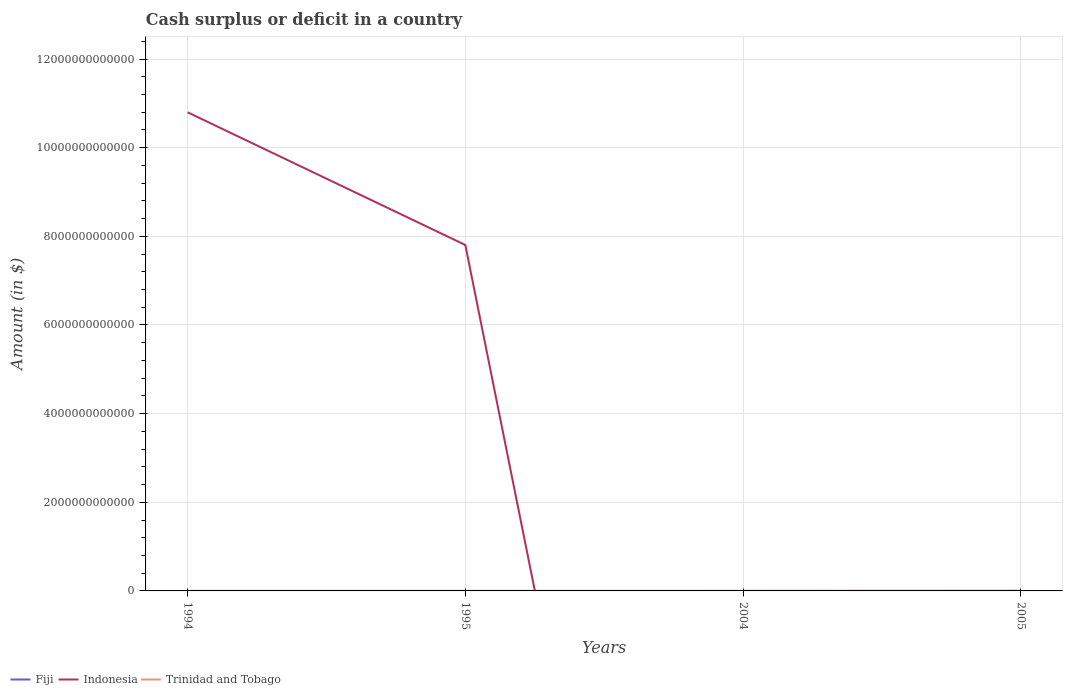Is the number of lines equal to the number of legend labels?
Offer a terse response. No. Across all years, what is the maximum amount of cash surplus or deficit in Indonesia?
Keep it short and to the point. 0. What is the total amount of cash surplus or deficit in Trinidad and Tobago in the graph?
Offer a terse response. -4.17e+09. Is the amount of cash surplus or deficit in Fiji strictly greater than the amount of cash surplus or deficit in Trinidad and Tobago over the years?
Your answer should be very brief. Yes. How many lines are there?
Give a very brief answer. 2. How many years are there in the graph?
Offer a very short reply. 4. What is the difference between two consecutive major ticks on the Y-axis?
Provide a short and direct response. 2.00e+12. How many legend labels are there?
Your answer should be compact. 3. What is the title of the graph?
Provide a short and direct response. Cash surplus or deficit in a country. What is the label or title of the Y-axis?
Provide a succinct answer. Amount (in $). What is the Amount (in $) of Indonesia in 1994?
Your answer should be compact. 1.08e+13. What is the Amount (in $) in Trinidad and Tobago in 1994?
Give a very brief answer. 1.14e+08. What is the Amount (in $) of Fiji in 1995?
Make the answer very short. 0. What is the Amount (in $) of Indonesia in 1995?
Provide a short and direct response. 7.80e+12. What is the Amount (in $) in Fiji in 2004?
Provide a short and direct response. 0. What is the Amount (in $) of Indonesia in 2004?
Provide a succinct answer. 0. What is the Amount (in $) in Trinidad and Tobago in 2004?
Your answer should be compact. 1.61e+09. What is the Amount (in $) of Fiji in 2005?
Provide a succinct answer. 0. What is the Amount (in $) of Trinidad and Tobago in 2005?
Provide a short and direct response. 5.78e+09. Across all years, what is the maximum Amount (in $) in Indonesia?
Your answer should be very brief. 1.08e+13. Across all years, what is the maximum Amount (in $) in Trinidad and Tobago?
Offer a very short reply. 5.78e+09. Across all years, what is the minimum Amount (in $) in Indonesia?
Your response must be concise. 0. Across all years, what is the minimum Amount (in $) in Trinidad and Tobago?
Offer a very short reply. 0. What is the total Amount (in $) of Indonesia in the graph?
Provide a short and direct response. 1.86e+13. What is the total Amount (in $) in Trinidad and Tobago in the graph?
Make the answer very short. 7.50e+09. What is the difference between the Amount (in $) in Indonesia in 1994 and that in 1995?
Your response must be concise. 2.99e+12. What is the difference between the Amount (in $) of Trinidad and Tobago in 1994 and that in 2004?
Offer a very short reply. -1.50e+09. What is the difference between the Amount (in $) of Trinidad and Tobago in 1994 and that in 2005?
Make the answer very short. -5.67e+09. What is the difference between the Amount (in $) of Trinidad and Tobago in 2004 and that in 2005?
Offer a terse response. -4.17e+09. What is the difference between the Amount (in $) of Indonesia in 1994 and the Amount (in $) of Trinidad and Tobago in 2004?
Provide a short and direct response. 1.08e+13. What is the difference between the Amount (in $) of Indonesia in 1994 and the Amount (in $) of Trinidad and Tobago in 2005?
Provide a succinct answer. 1.08e+13. What is the difference between the Amount (in $) of Indonesia in 1995 and the Amount (in $) of Trinidad and Tobago in 2004?
Your answer should be compact. 7.80e+12. What is the difference between the Amount (in $) of Indonesia in 1995 and the Amount (in $) of Trinidad and Tobago in 2005?
Provide a succinct answer. 7.80e+12. What is the average Amount (in $) in Indonesia per year?
Give a very brief answer. 4.65e+12. What is the average Amount (in $) in Trinidad and Tobago per year?
Ensure brevity in your answer.  1.88e+09. In the year 1994, what is the difference between the Amount (in $) in Indonesia and Amount (in $) in Trinidad and Tobago?
Offer a terse response. 1.08e+13. What is the ratio of the Amount (in $) in Indonesia in 1994 to that in 1995?
Provide a short and direct response. 1.38. What is the ratio of the Amount (in $) in Trinidad and Tobago in 1994 to that in 2004?
Your answer should be compact. 0.07. What is the ratio of the Amount (in $) in Trinidad and Tobago in 1994 to that in 2005?
Your answer should be very brief. 0.02. What is the ratio of the Amount (in $) of Trinidad and Tobago in 2004 to that in 2005?
Offer a very short reply. 0.28. What is the difference between the highest and the second highest Amount (in $) in Trinidad and Tobago?
Provide a succinct answer. 4.17e+09. What is the difference between the highest and the lowest Amount (in $) of Indonesia?
Offer a very short reply. 1.08e+13. What is the difference between the highest and the lowest Amount (in $) in Trinidad and Tobago?
Keep it short and to the point. 5.78e+09. 